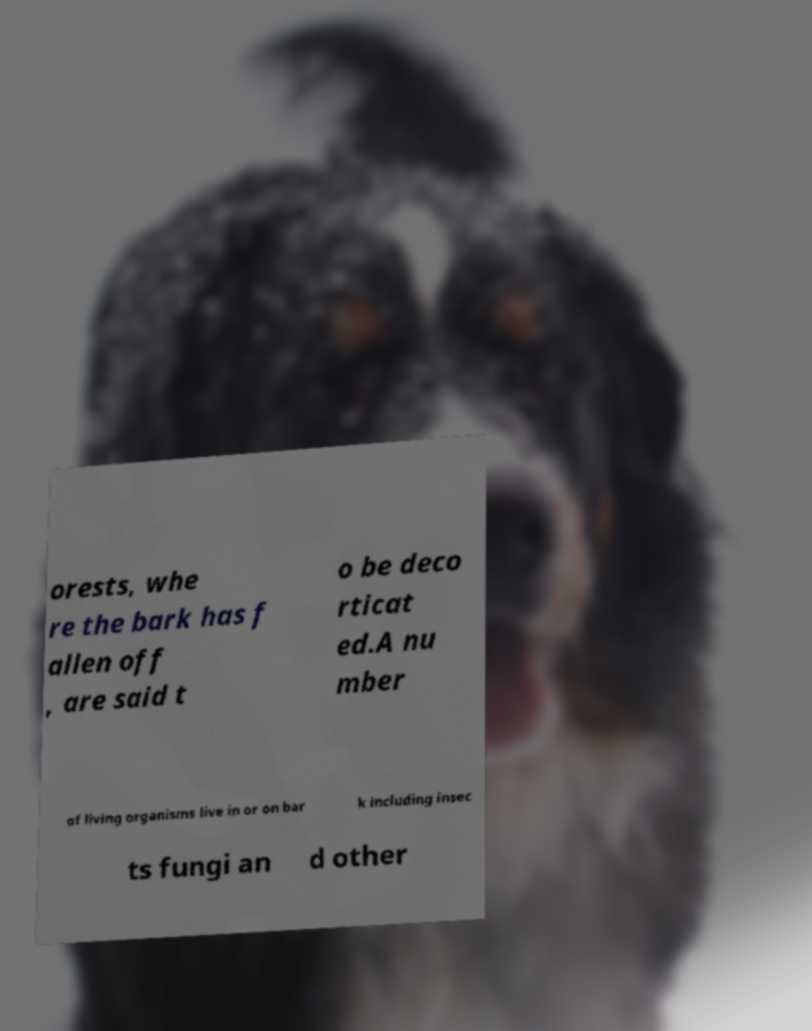Could you assist in decoding the text presented in this image and type it out clearly? orests, whe re the bark has f allen off , are said t o be deco rticat ed.A nu mber of living organisms live in or on bar k including insec ts fungi an d other 